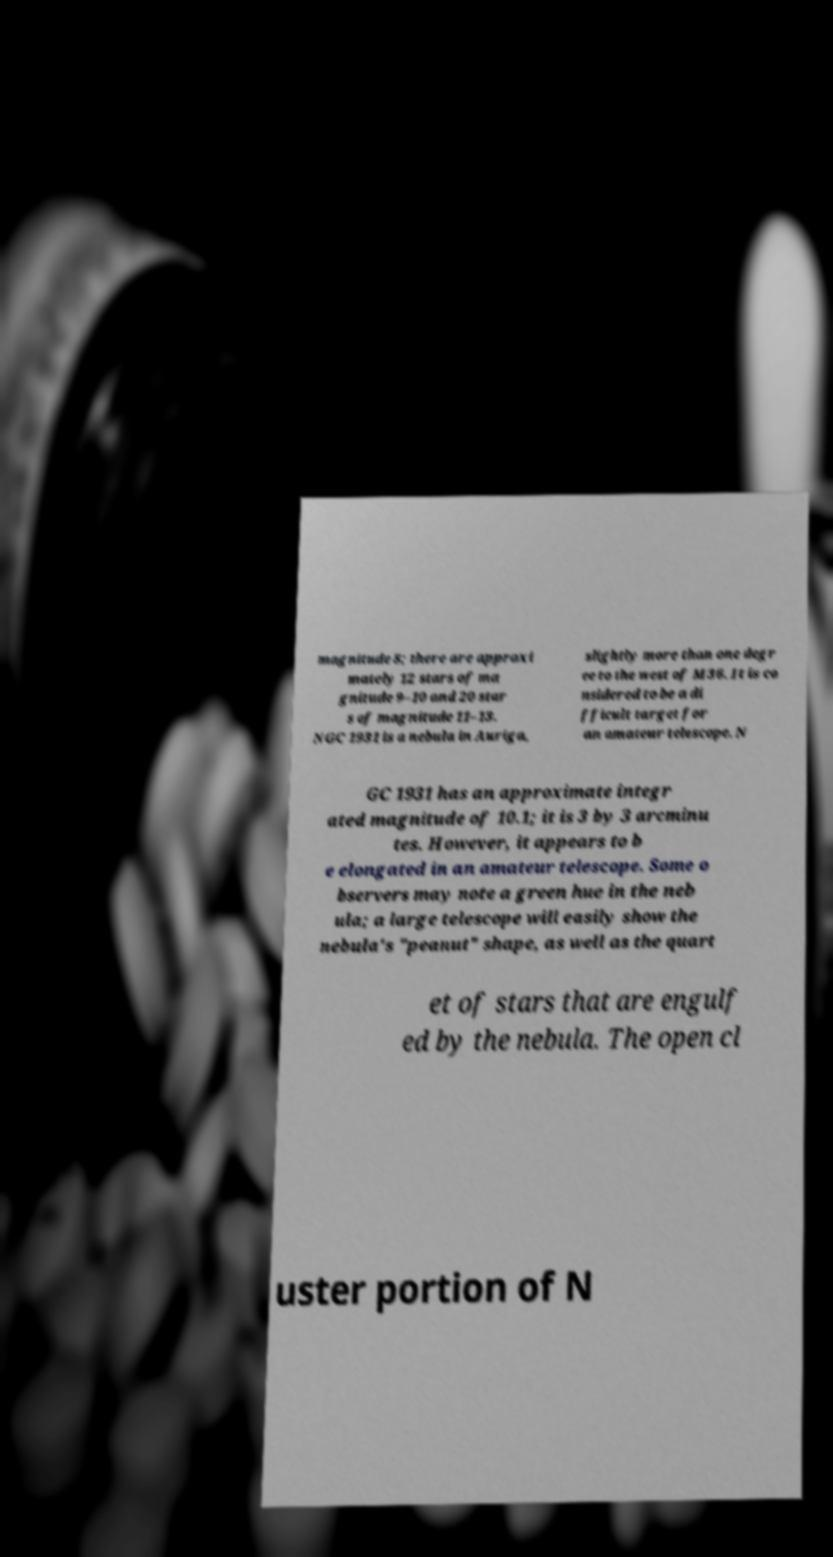Can you read and provide the text displayed in the image?This photo seems to have some interesting text. Can you extract and type it out for me? magnitude 8; there are approxi mately 12 stars of ma gnitude 9–10 and 20 star s of magnitude 11–13. NGC 1931 is a nebula in Auriga, slightly more than one degr ee to the west of M36. It is co nsidered to be a di fficult target for an amateur telescope. N GC 1931 has an approximate integr ated magnitude of 10.1; it is 3 by 3 arcminu tes. However, it appears to b e elongated in an amateur telescope. Some o bservers may note a green hue in the neb ula; a large telescope will easily show the nebula's "peanut" shape, as well as the quart et of stars that are engulf ed by the nebula. The open cl uster portion of N 